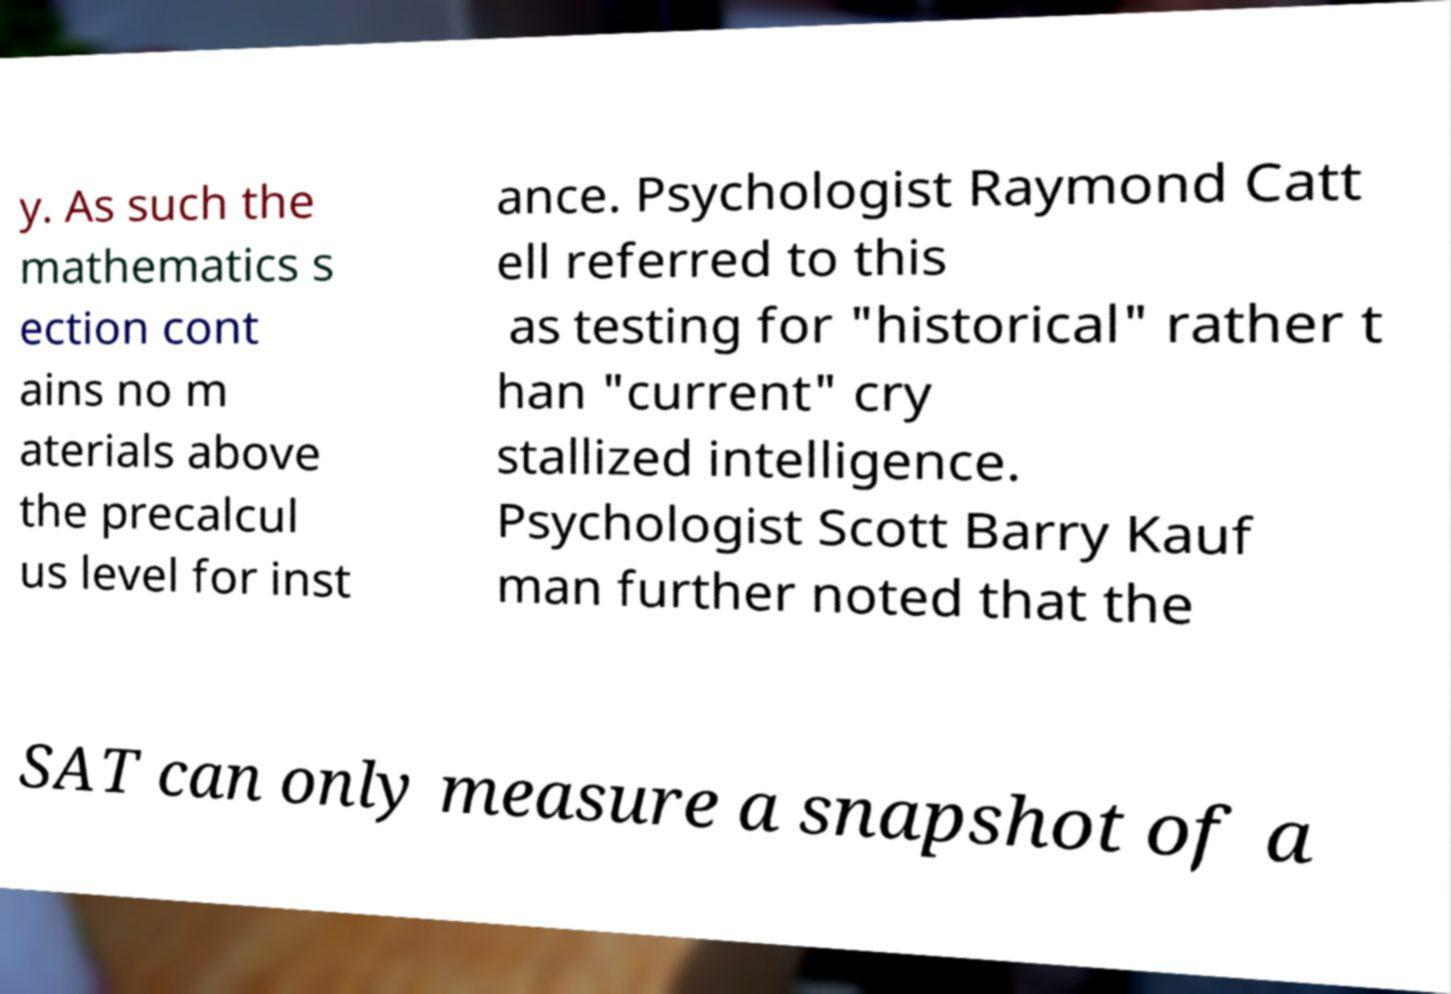Could you extract and type out the text from this image? y. As such the mathematics s ection cont ains no m aterials above the precalcul us level for inst ance. Psychologist Raymond Catt ell referred to this as testing for "historical" rather t han "current" cry stallized intelligence. Psychologist Scott Barry Kauf man further noted that the SAT can only measure a snapshot of a 